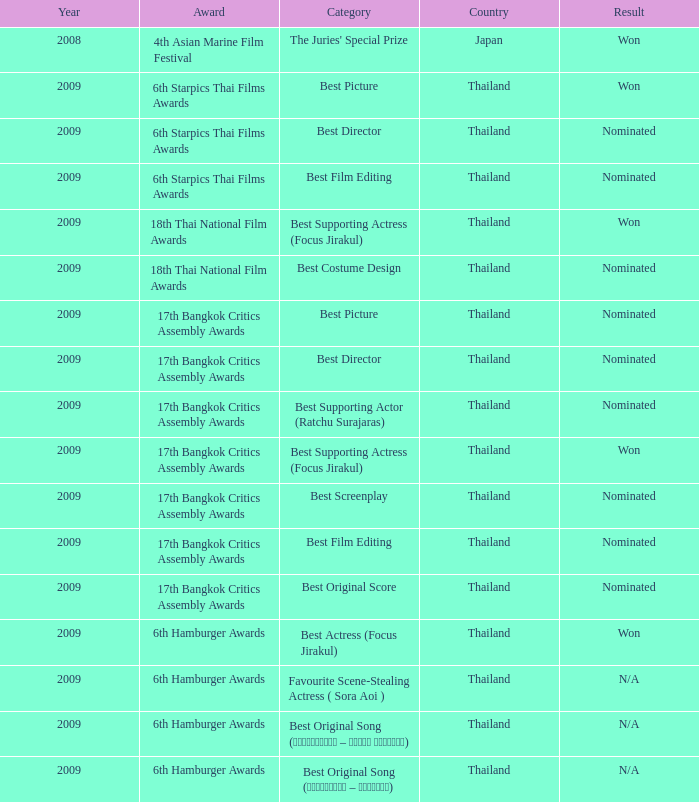Could you parse the entire table? {'header': ['Year', 'Award', 'Category', 'Country', 'Result'], 'rows': [['2008', '4th Asian Marine Film Festival', "The Juries' Special Prize", 'Japan', 'Won'], ['2009', '6th Starpics Thai Films Awards', 'Best Picture', 'Thailand', 'Won'], ['2009', '6th Starpics Thai Films Awards', 'Best Director', 'Thailand', 'Nominated'], ['2009', '6th Starpics Thai Films Awards', 'Best Film Editing', 'Thailand', 'Nominated'], ['2009', '18th Thai National Film Awards', 'Best Supporting Actress (Focus Jirakul)', 'Thailand', 'Won'], ['2009', '18th Thai National Film Awards', 'Best Costume Design', 'Thailand', 'Nominated'], ['2009', '17th Bangkok Critics Assembly Awards', 'Best Picture', 'Thailand', 'Nominated'], ['2009', '17th Bangkok Critics Assembly Awards', 'Best Director', 'Thailand', 'Nominated'], ['2009', '17th Bangkok Critics Assembly Awards', 'Best Supporting Actor (Ratchu Surajaras)', 'Thailand', 'Nominated'], ['2009', '17th Bangkok Critics Assembly Awards', 'Best Supporting Actress (Focus Jirakul)', 'Thailand', 'Won'], ['2009', '17th Bangkok Critics Assembly Awards', 'Best Screenplay', 'Thailand', 'Nominated'], ['2009', '17th Bangkok Critics Assembly Awards', 'Best Film Editing', 'Thailand', 'Nominated'], ['2009', '17th Bangkok Critics Assembly Awards', 'Best Original Score', 'Thailand', 'Nominated'], ['2009', '6th Hamburger Awards', 'Best Actress (Focus Jirakul)', 'Thailand', 'Won'], ['2009', '6th Hamburger Awards', 'Favourite Scene-Stealing Actress ( Sora Aoi )', 'Thailand', 'N/A'], ['2009', '6th Hamburger Awards', 'Best Original Song (รอเธอหันมา – โฟกัส จิระกุล)', 'Thailand', 'N/A'], ['2009', '6th Hamburger Awards', 'Best Original Song (อย่างน้อย – บิ๊กแอส)', 'Thailand', 'N/A']]} Which Year has a Category of best original song (รอเธอหันมา – โฟกัส จิระกุล)? 2009.0. 